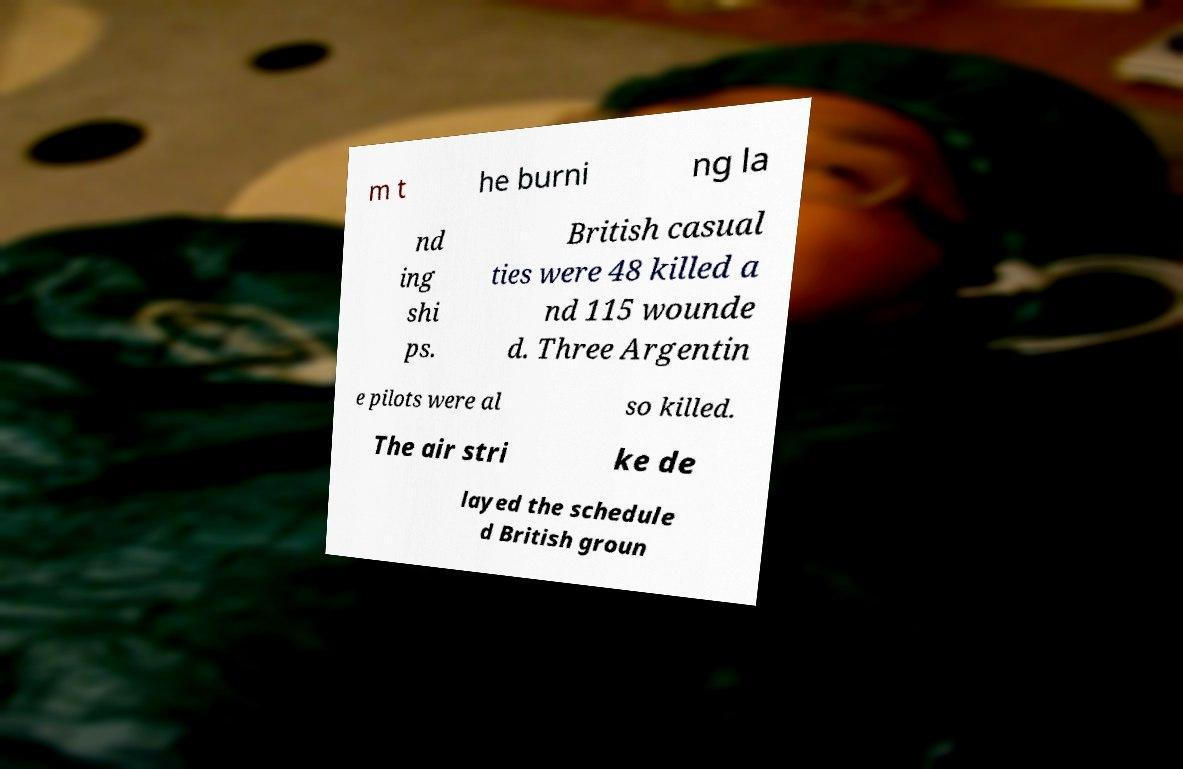There's text embedded in this image that I need extracted. Can you transcribe it verbatim? m t he burni ng la nd ing shi ps. British casual ties were 48 killed a nd 115 wounde d. Three Argentin e pilots were al so killed. The air stri ke de layed the schedule d British groun 